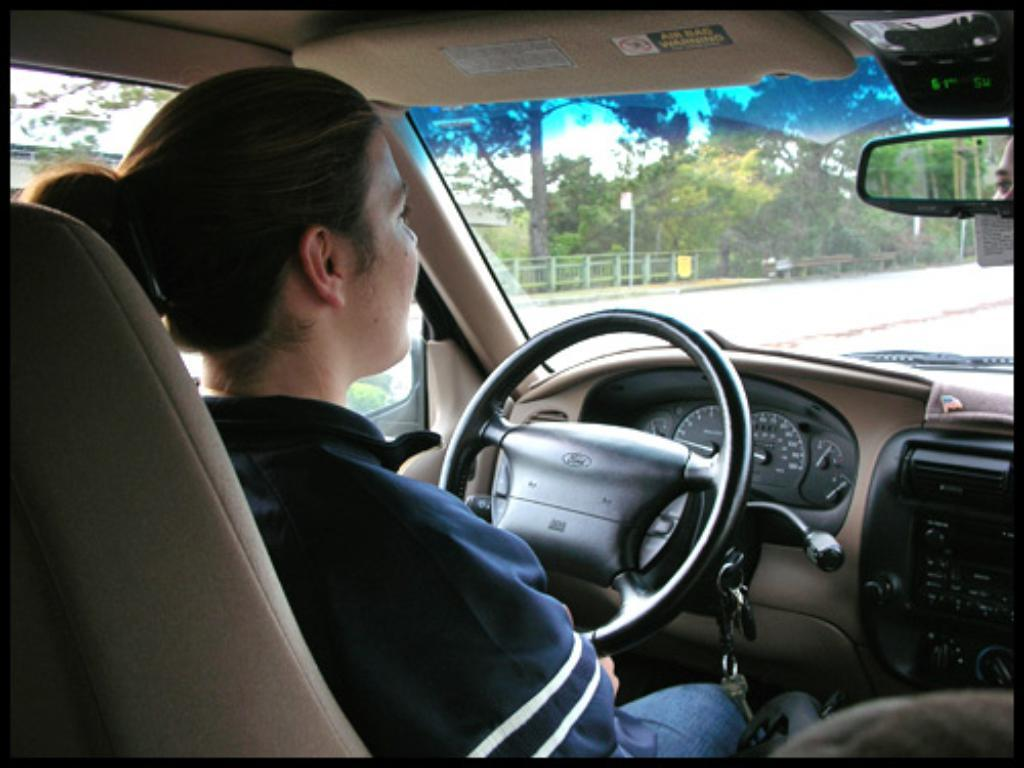What is inside the vehicle in the image? There is a person inside the vehicle. Can you describe any specific features of the vehicle? There is a mirror visible in the image. What type of natural environment can be seen in the image? Trees are visible in the image. What type of poison is being used by the person in the vehicle? There is no indication of any poison being used in the image; the person is simply inside the vehicle. 